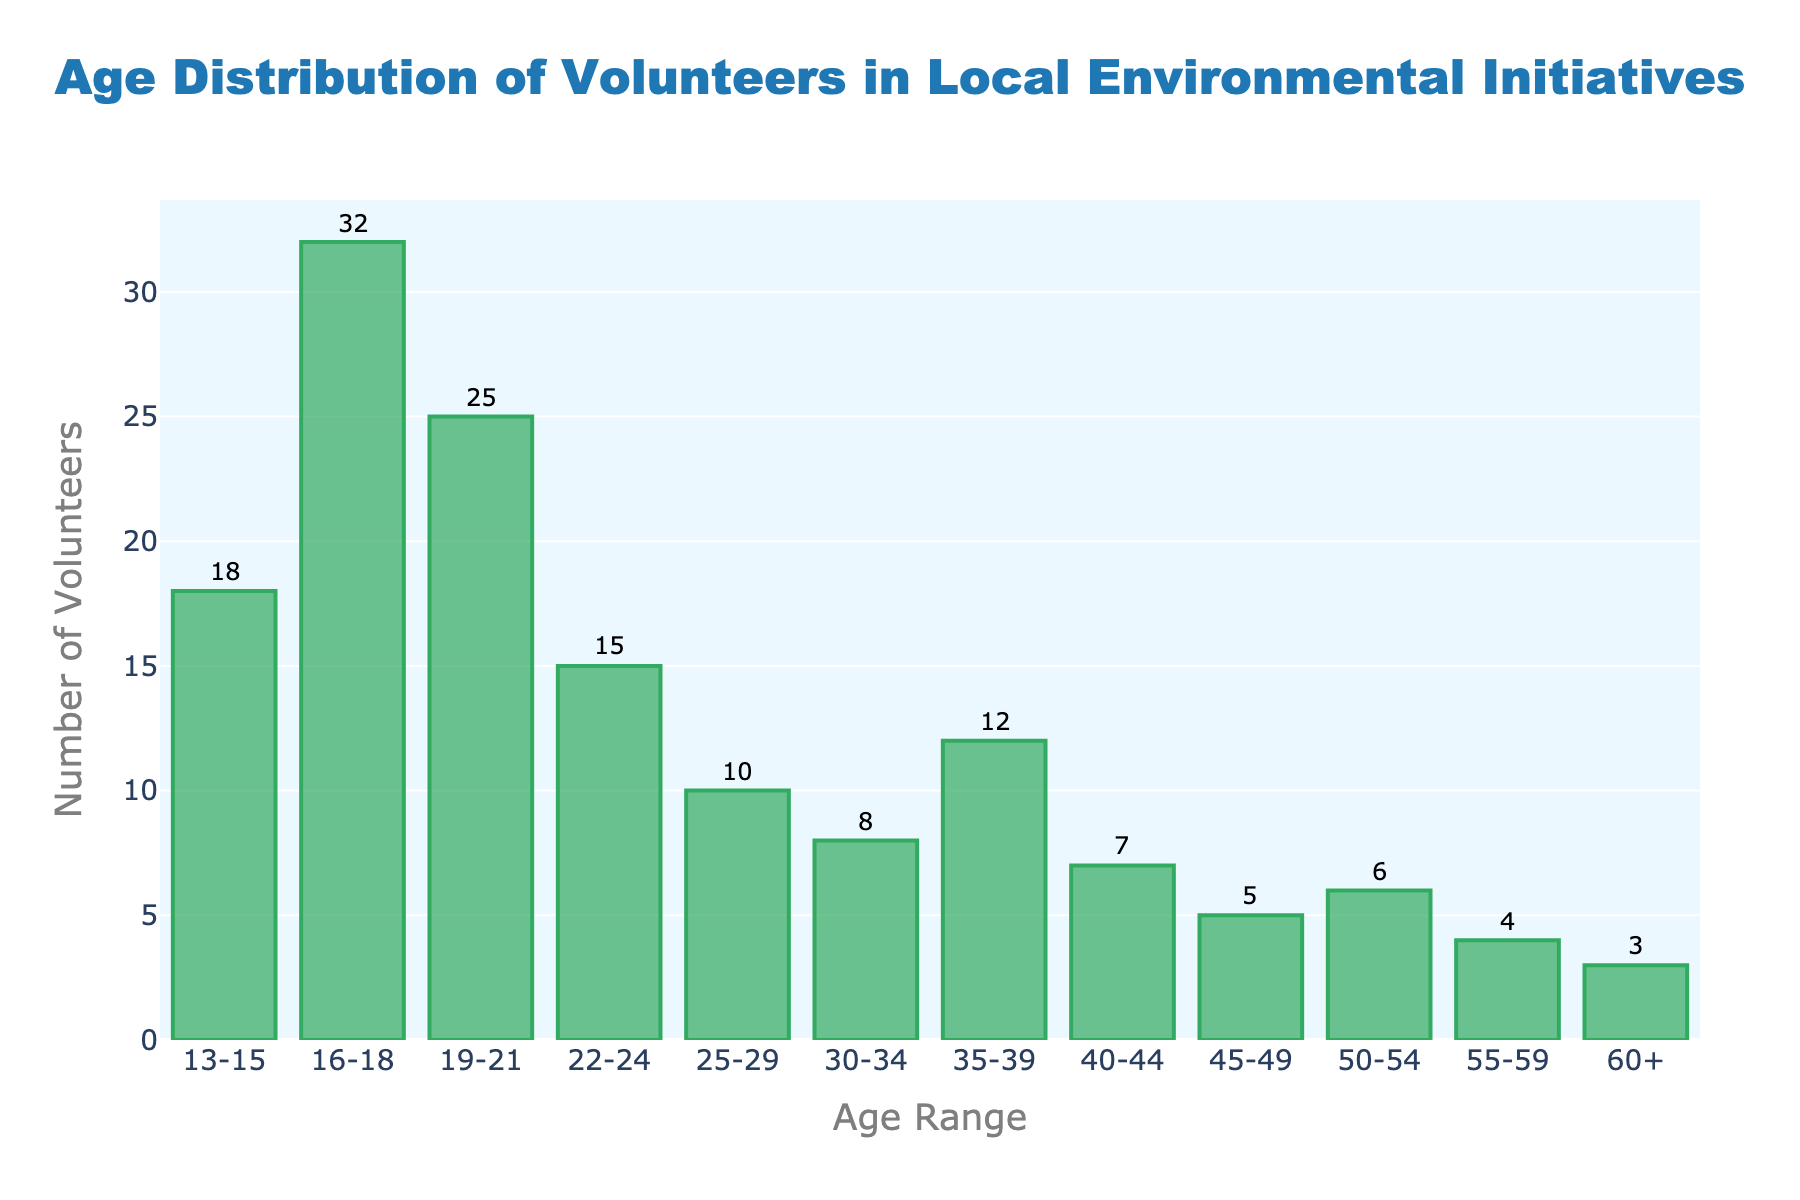what is the title of the histogram? The title is written at the top-center of the histogram. It reads 'Age Distribution of Volunteers in Local Environmental Initiatives'.
Answer: Age Distribution of Volunteers in Local Environmental Initiatives Which age group has the highest number of volunteers? By looking at the height of the bars, the age group with the highest bar is '16-18'. Thus, it has the highest number of volunteers.
Answer: 16-18 What is the number of volunteers in the 25-29 age group? The bar corresponding to the '25-29' age range reaches up to the value '10' on the y-axis, indicating the number of volunteers.
Answer: 10 Which age groups have fewer than 10 volunteers? Observing the bars, those below the y-axis value of '10' include 30-34 (8), 40-44 (7), 45-49 (5), 50-54 (6), 55-59 (4), and 60+ (3).
Answer: 30-34, 40-44, 45-49, 50-54, 55-59, 60+ How many total volunteers are there aged 22-24 and 25-29? Adding the number of volunteers in the '22-24' (15) and '25-29' (10) age groups, the total is 15 + 10 = 25.
Answer: 25 Which age group has more volunteers: 19-21 or 35-39? Comparing the heights of the bars, '19-21' (25) is taller than '35-39' (12), indicating more volunteers in the '19-21' age group.
Answer: 19-21 What's the age range with the third most volunteers? By viewing the bars in descending order, the age groups are 16-18 (32), 19-21 (25), and 13-15 (18). Therefore, '13-15' has the third most volunteers.
Answer: 13-15 How many volunteers are there in total for age ranges 50-54 and above? Summing the volunteers from age ranges '50-54' (6), '55-59' (4), and '60+' (3) totals to 6 + 4 + 3 = 13.
Answer: 13 What is the difference in the number of volunteers between the youngest (13-15) and the oldest (60+) age groups? Subtracting the number of volunteers in the '60+' (3) from '13-15' (18) results in 18 - 3 = 15.
Answer: 15 What is the average number of volunteers across all age groups? Summing all volunteer numbers: (18+32+25+15+10+8+12+7+5+6+4+3)=145. There are 12 age groups, so 145/12 = 12.083 (approximately 12.1).
Answer: 12.1 